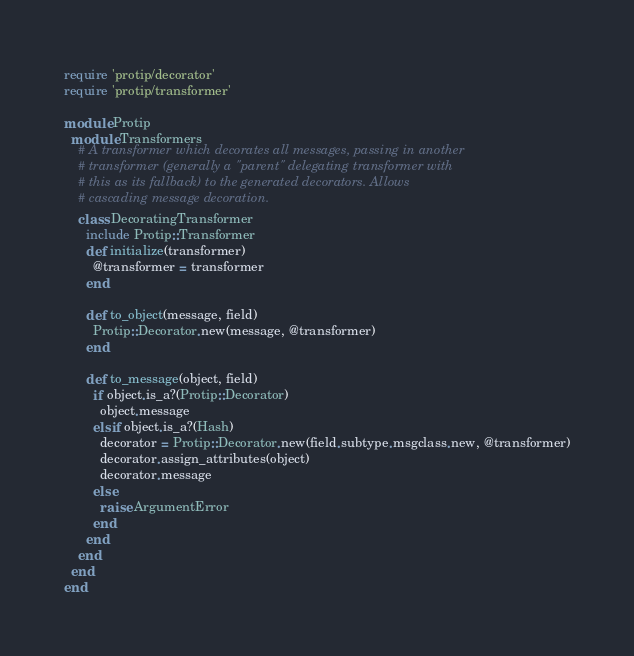Convert code to text. <code><loc_0><loc_0><loc_500><loc_500><_Ruby_>require 'protip/decorator'
require 'protip/transformer'

module Protip
  module Transformers
    # A transformer which decorates all messages, passing in another
    # transformer (generally a "parent" delegating transformer with
    # this as its fallback) to the generated decorators. Allows
    # cascading message decoration.
    class DecoratingTransformer
      include Protip::Transformer
      def initialize(transformer)
        @transformer = transformer
      end

      def to_object(message, field)
        Protip::Decorator.new(message, @transformer)
      end

      def to_message(object, field)
        if object.is_a?(Protip::Decorator)
          object.message
        elsif object.is_a?(Hash)
          decorator = Protip::Decorator.new(field.subtype.msgclass.new, @transformer)
          decorator.assign_attributes(object)
          decorator.message
        else
          raise ArgumentError
        end
      end
    end
  end
end
</code> 